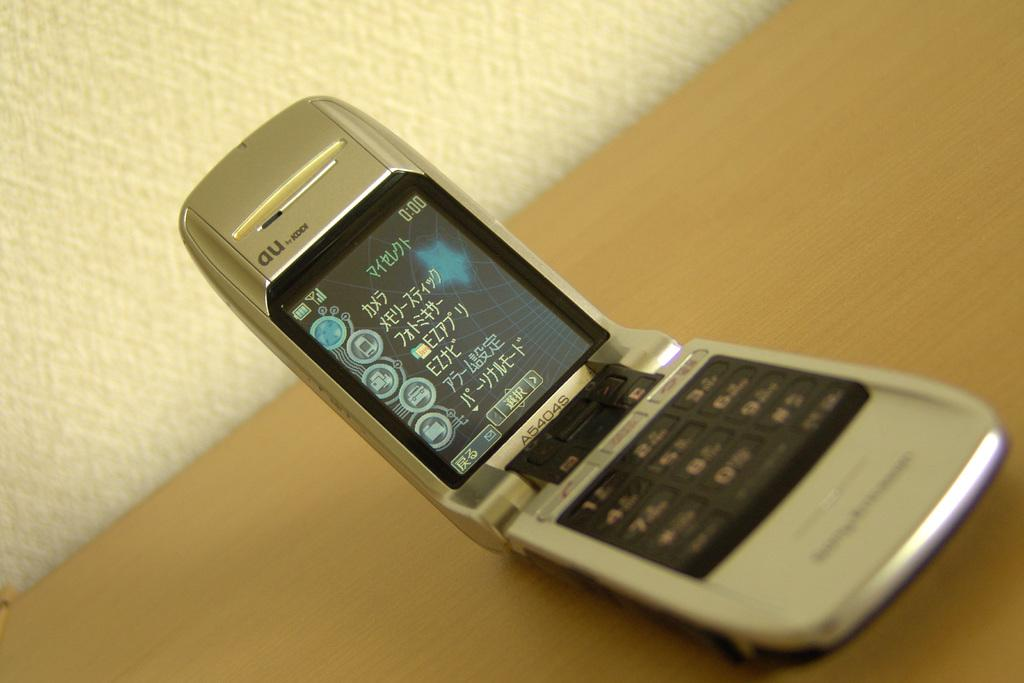<image>
Write a terse but informative summary of the picture. The silver flip phone has a model number of A5404S written on it near the hinge. 